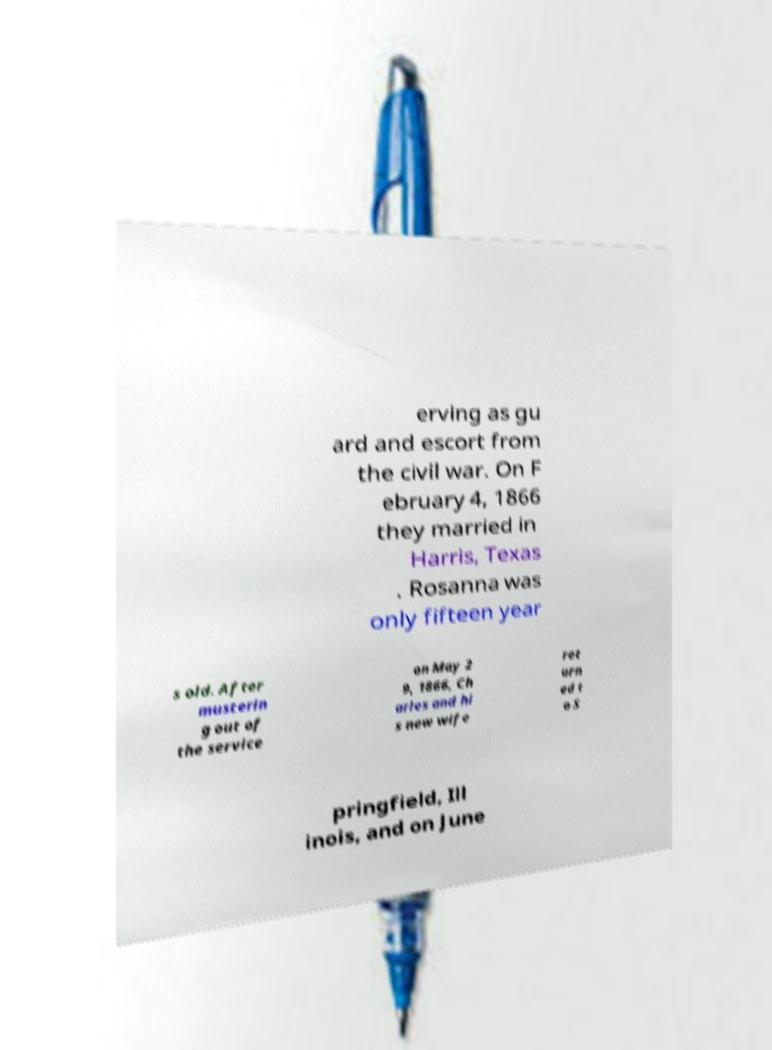There's text embedded in this image that I need extracted. Can you transcribe it verbatim? erving as gu ard and escort from the civil war. On F ebruary 4, 1866 they married in Harris, Texas . Rosanna was only fifteen year s old. After musterin g out of the service on May 2 9, 1866, Ch arles and hi s new wife ret urn ed t o S pringfield, Ill inois, and on June 